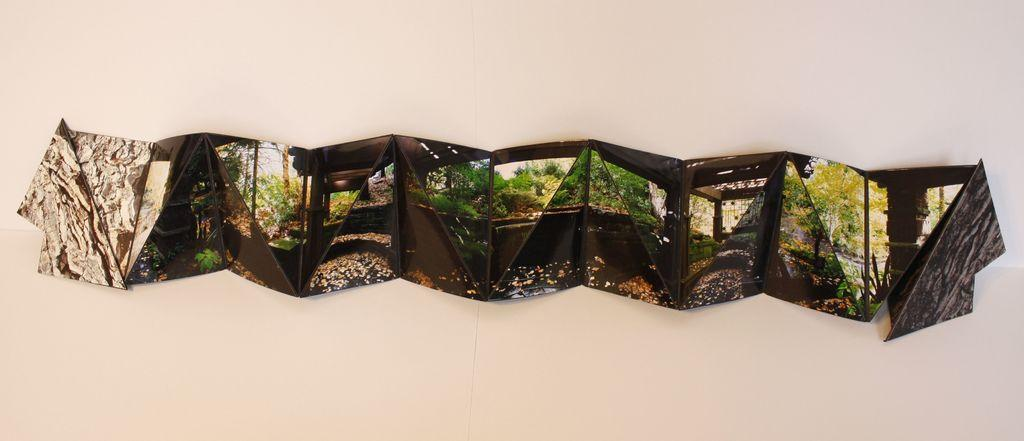What type of object contains trees in the image? There is an object containing trees in the image, but the specific type of object is not mentioned. Where is the object with trees placed? The object is placed on a white surface. What is the rate of existence for the rifle in the image? There is no rifle present in the image, so the rate of existence cannot be determined. 